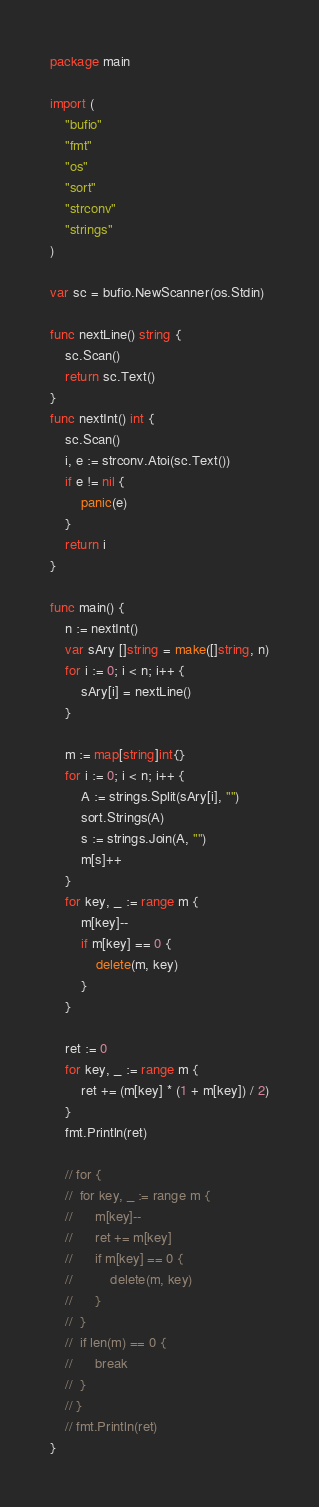Convert code to text. <code><loc_0><loc_0><loc_500><loc_500><_Go_>package main

import (
	"bufio"
	"fmt"
	"os"
	"sort"
	"strconv"
	"strings"
)

var sc = bufio.NewScanner(os.Stdin)

func nextLine() string {
	sc.Scan()
	return sc.Text()
}
func nextInt() int {
	sc.Scan()
	i, e := strconv.Atoi(sc.Text())
	if e != nil {
		panic(e)
	}
	return i
}

func main() {
	n := nextInt()
	var sAry []string = make([]string, n)
	for i := 0; i < n; i++ {
		sAry[i] = nextLine()
	}

	m := map[string]int{}
	for i := 0; i < n; i++ {
		A := strings.Split(sAry[i], "")
		sort.Strings(A)
		s := strings.Join(A, "")
		m[s]++
	}
	for key, _ := range m {
		m[key]--
		if m[key] == 0 {
			delete(m, key)
		}
	}

	ret := 0
	for key, _ := range m {
		ret += (m[key] * (1 + m[key]) / 2)
	}
	fmt.Println(ret)

	// for {
	// 	for key, _ := range m {
	// 		m[key]--
	// 		ret += m[key]
	// 		if m[key] == 0 {
	// 			delete(m, key)
	// 		}
	// 	}
	// 	if len(m) == 0 {
	// 		break
	// 	}
	// }
	// fmt.Println(ret)
}
</code> 